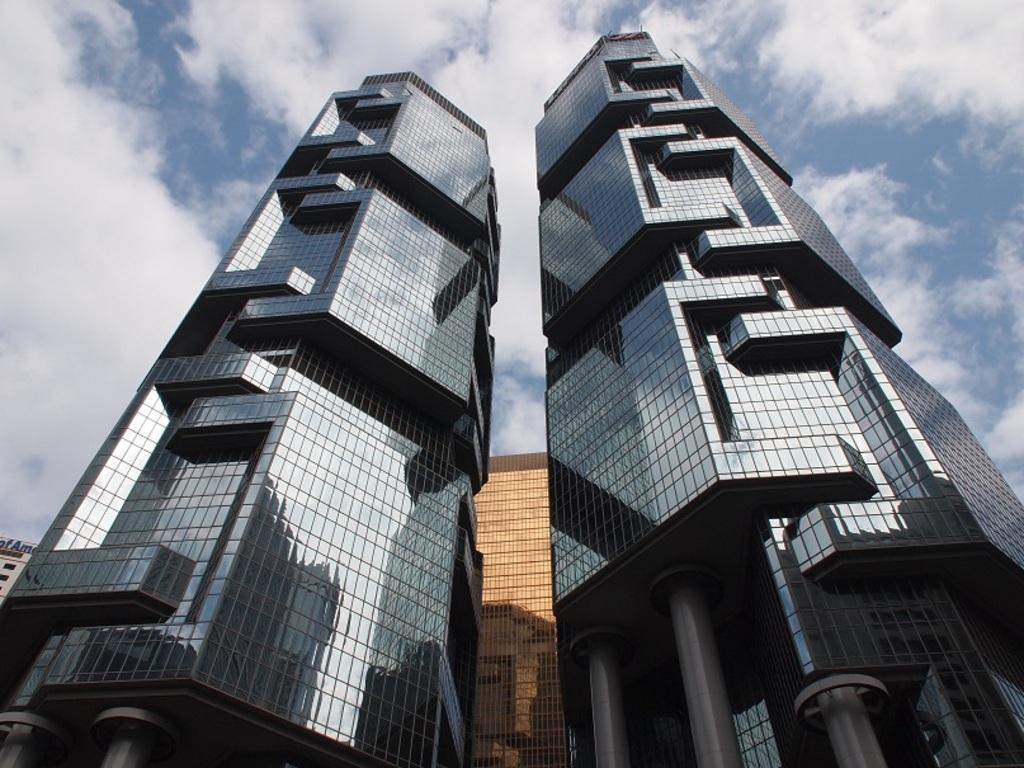What type of structures can be seen in the image? There are buildings in the image. What is visible in the background of the image? Sky is visible in the background of the image. What can be observed in the sky? Clouds are present in the sky. How many bananas can be seen hanging from the buildings in the image? There are no bananas present in the image; it features buildings and clouds in the sky. 